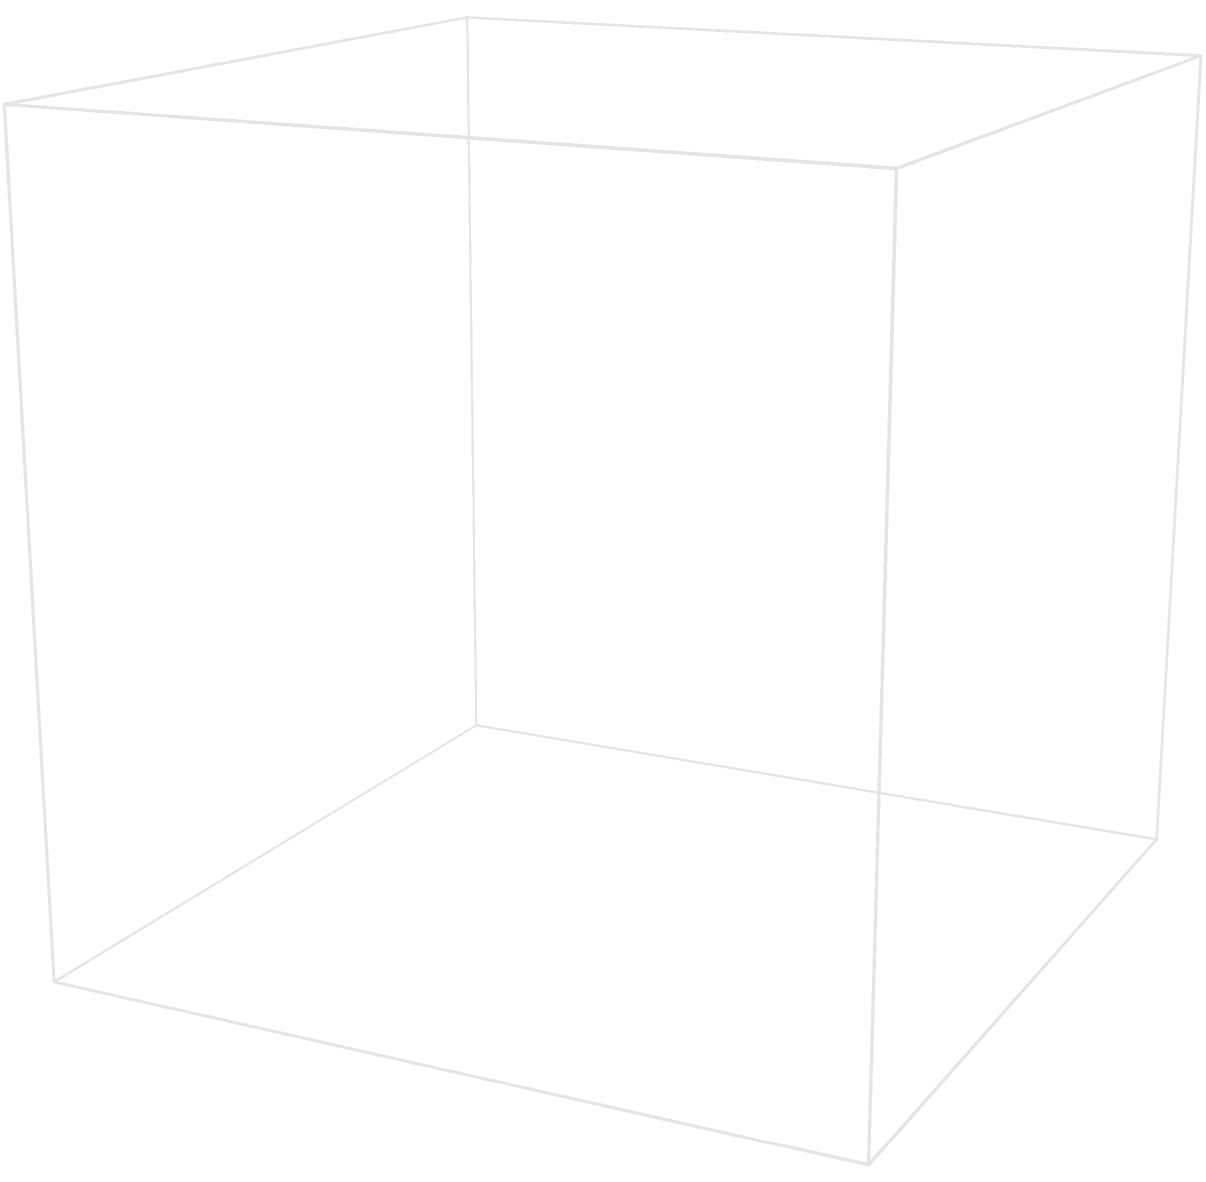In the diagram of a Russian Orthodox church, how many onion domes would be visible if viewed directly from the front (facing the side with two domes)? To determine the number of visible onion domes from the front view, let's analyze the structure step-by-step:

1. The church has a total of 5 onion domes:
   - 4 smaller domes at each corner of the roof
   - 1 larger central dome

2. When viewed from the front:
   - The 2 domes at the front edge of the roof will be fully visible
   - The central dome, being taller and larger, will also be visible
   - The 2 domes at the back edge of the roof will be hidden behind the front domes

3. Therefore, from a direct front view, we would see:
   - 2 smaller domes (front edge)
   - 1 larger central dome

4. Total visible domes: $2 + 1 = 3$

This perspective is particularly important in Russian Orthodox architecture, where the number and arrangement of domes often have symbolic meanings related to the Holy Trinity or the Evangelists.
Answer: 3 domes 